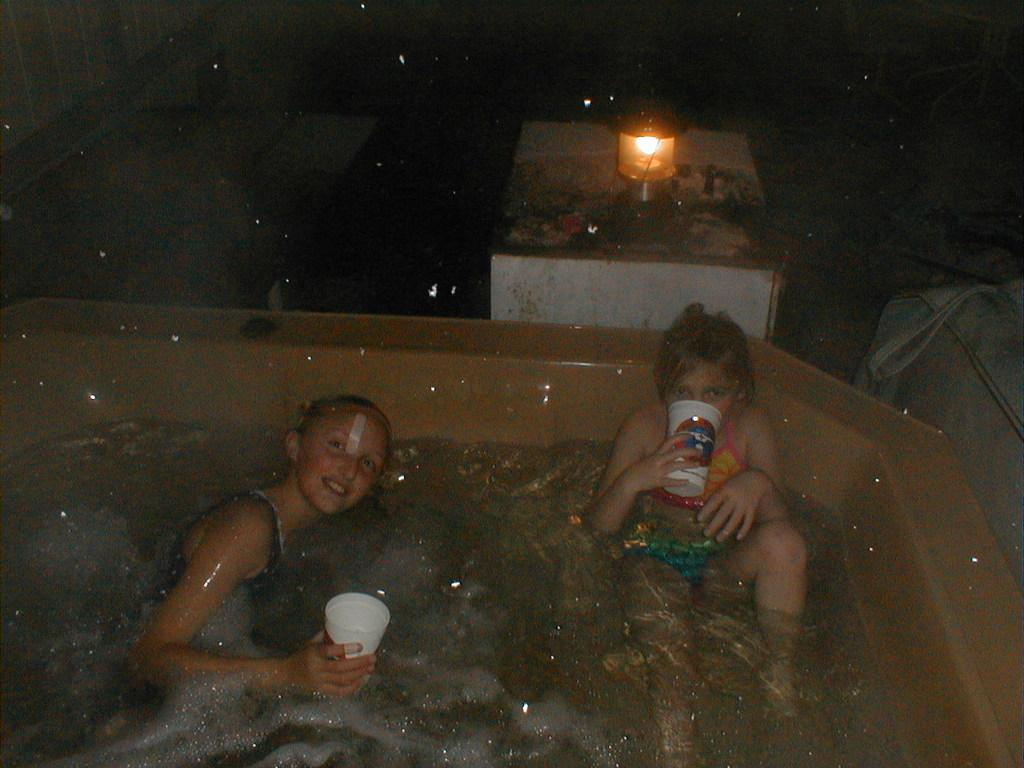How many people are in the bathtub in the image? There are two persons in the bathtub in the image. What are the persons holding in the image? The persons are holding cups in the image. What object can be seen in the image besides the persons and cups? There is a bag in the image. What piece of furniture is present in the image? There is a table in the image. What is on the table in the image? There is a lamp on the table in the image. What type of home does the son live in, as seen in the image? The image does not show a home or a son, so it is not possible to determine the type of home the son lives in. 